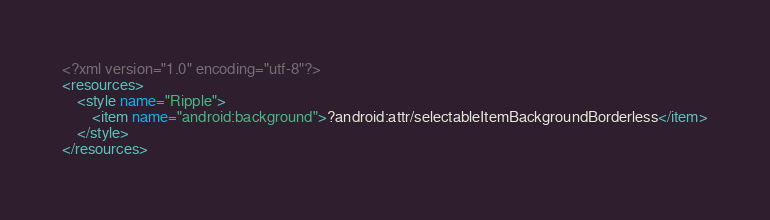<code> <loc_0><loc_0><loc_500><loc_500><_XML_><?xml version="1.0" encoding="utf-8"?>
<resources>
    <style name="Ripple">
        <item name="android:background">?android:attr/selectableItemBackgroundBorderless</item>
    </style>
</resources></code> 